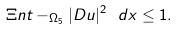<formula> <loc_0><loc_0><loc_500><loc_500>\Xi n t - _ { \Omega _ { 5 } } | D u | ^ { 2 } \ d x \leq 1 .</formula> 